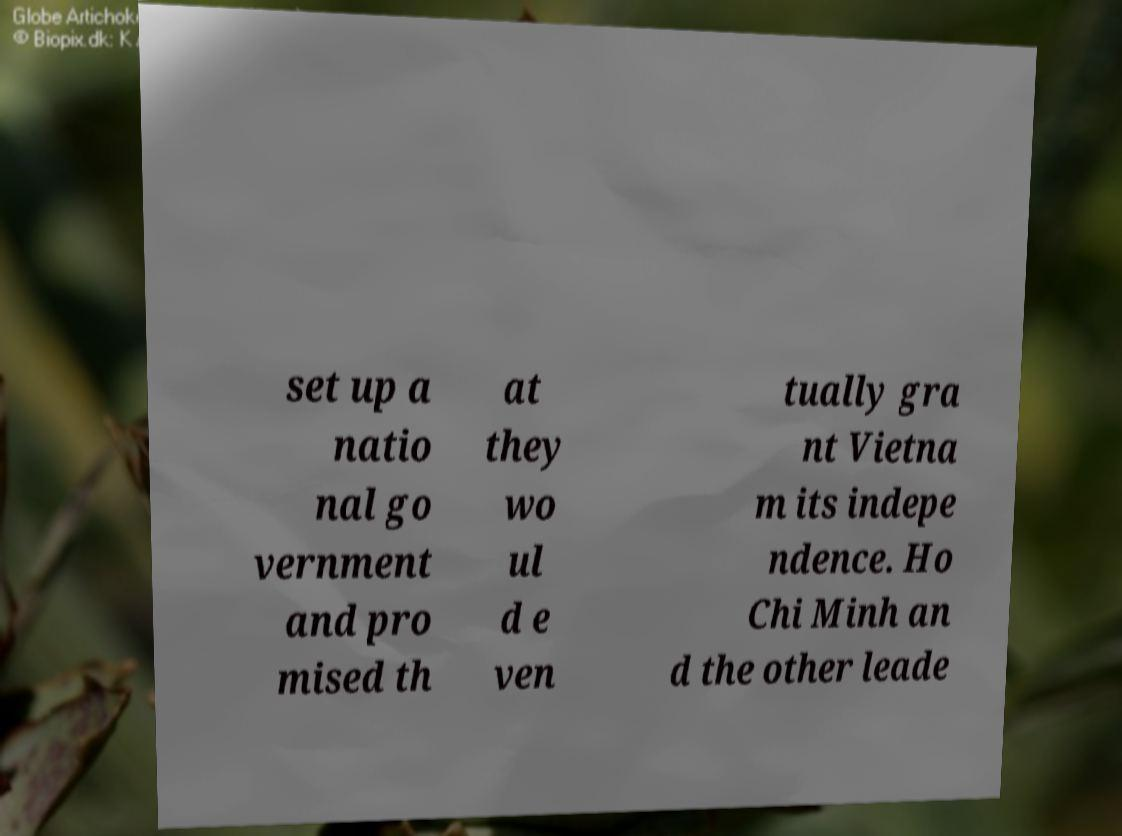For documentation purposes, I need the text within this image transcribed. Could you provide that? set up a natio nal go vernment and pro mised th at they wo ul d e ven tually gra nt Vietna m its indepe ndence. Ho Chi Minh an d the other leade 